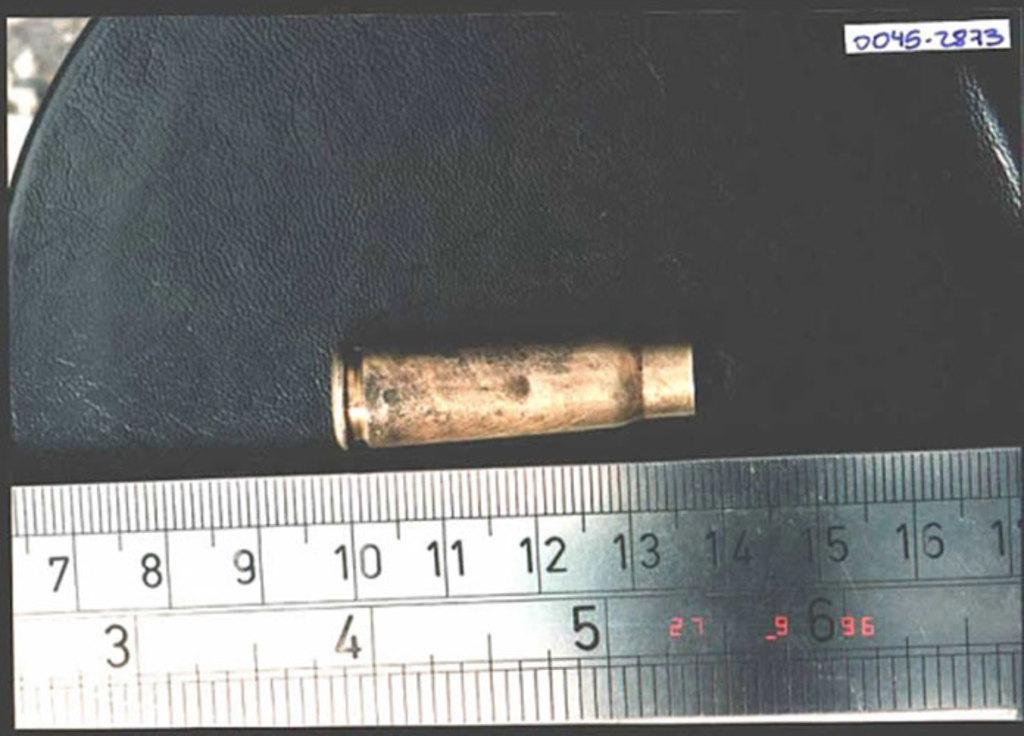Provide a one-sentence caption for the provided image. A bullet is next to a metal ruler, and measures from 10 to 14 centimeters. 